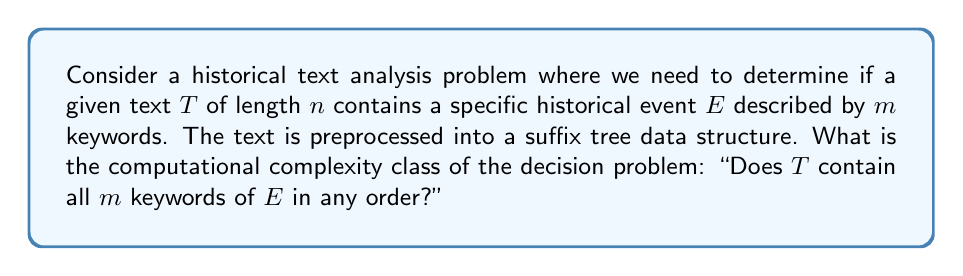What is the answer to this math problem? To solve this problem, we need to consider the following steps:

1. Preprocessing:
   The text T is preprocessed into a suffix tree. This can be done in $O(n)$ time and space for a text of length n using Ukkonen's algorithm.

2. Keyword search:
   For each of the m keywords, we need to search the suffix tree. Each search takes $O(|k_i|)$ time, where $|k_i|$ is the length of the i-th keyword.

3. Decision:
   After finding all keywords, we need to determine if they all exist in the text.

Let's analyze the time complexity:

1. Suffix tree construction: $O(n)$
2. Keyword searches: $O(\sum_{i=1}^m |k_i|)$, which is bounded by $O(m \cdot \max(|k_i|))$
3. Decision: $O(m)$ to check if all keywords were found

The total time complexity is:

$$O(n + m \cdot \max(|k_i|) + m)$$

Since $\max(|k_i|)$ is typically much smaller than n for historical event descriptions, we can simplify this to:

$$O(n + m)$$

The space complexity is dominated by the suffix tree, which is $O(n)$.

This problem can be solved deterministically in polynomial time with respect to the input size (n + m). Therefore, the decision problem belongs to the complexity class P (Polynomial Time).

It's worth noting that this solution is efficient for multiple queries on the same text, as the suffix tree is constructed only once and can be reused for different historical events.
Answer: The computational complexity class of the decision problem "Does T contain all m keywords of E in any order?" is P (Polynomial Time). 